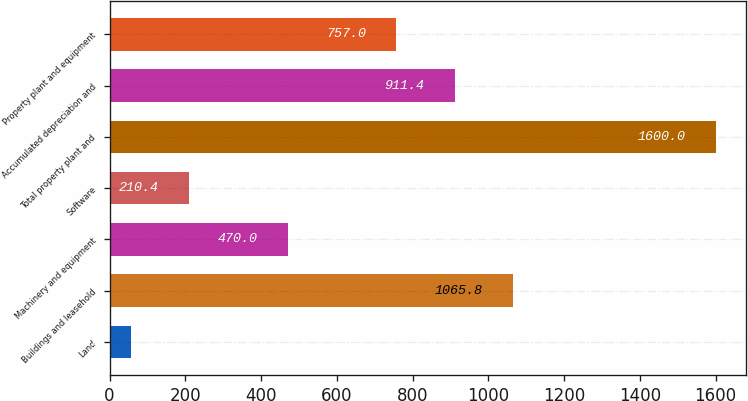Convert chart. <chart><loc_0><loc_0><loc_500><loc_500><bar_chart><fcel>Land<fcel>Buildings and leasehold<fcel>Machinery and equipment<fcel>Software<fcel>Total property plant and<fcel>Accumulated depreciation and<fcel>Property plant and equipment<nl><fcel>56<fcel>1065.8<fcel>470<fcel>210.4<fcel>1600<fcel>911.4<fcel>757<nl></chart> 